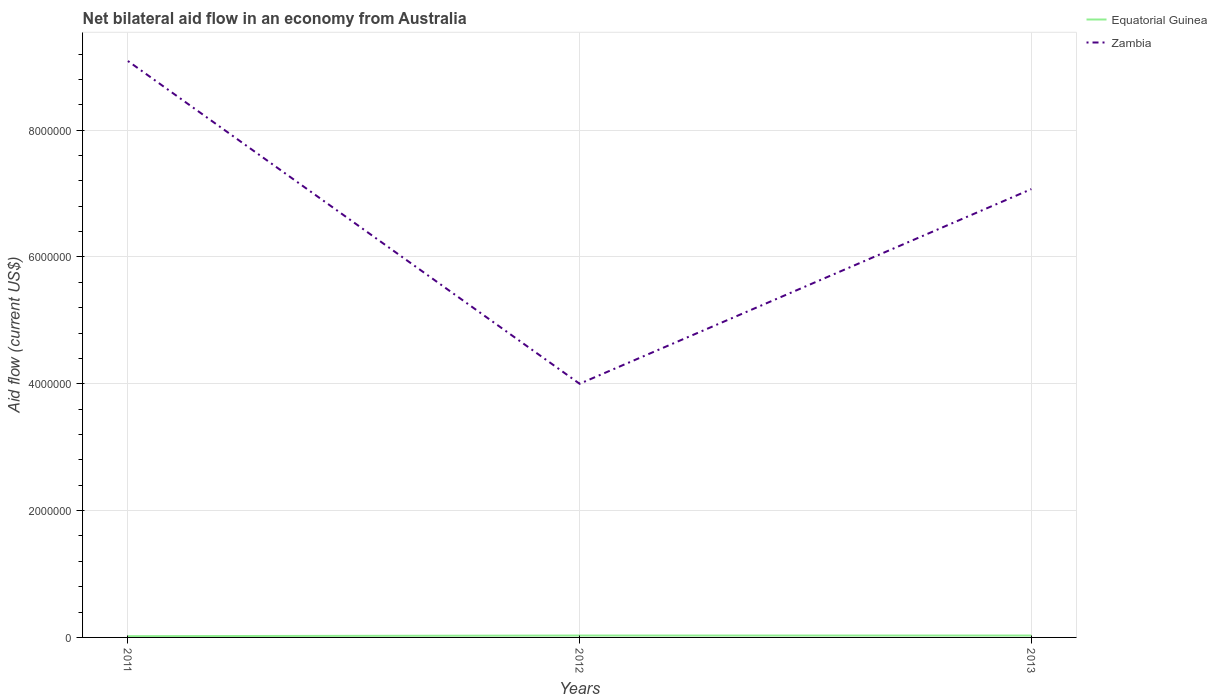Does the line corresponding to Zambia intersect with the line corresponding to Equatorial Guinea?
Make the answer very short. No. Across all years, what is the maximum net bilateral aid flow in Zambia?
Make the answer very short. 4.00e+06. What is the total net bilateral aid flow in Equatorial Guinea in the graph?
Your answer should be compact. 0. What is the difference between the highest and the second highest net bilateral aid flow in Equatorial Guinea?
Your answer should be very brief. 10000. How many years are there in the graph?
Provide a short and direct response. 3. Does the graph contain any zero values?
Keep it short and to the point. No. Does the graph contain grids?
Provide a short and direct response. Yes. How are the legend labels stacked?
Provide a short and direct response. Vertical. What is the title of the graph?
Your answer should be compact. Net bilateral aid flow in an economy from Australia. What is the Aid flow (current US$) in Equatorial Guinea in 2011?
Keep it short and to the point. 2.00e+04. What is the Aid flow (current US$) of Zambia in 2011?
Ensure brevity in your answer.  9.09e+06. What is the Aid flow (current US$) of Equatorial Guinea in 2012?
Your answer should be very brief. 3.00e+04. What is the Aid flow (current US$) in Zambia in 2012?
Offer a very short reply. 4.00e+06. What is the Aid flow (current US$) in Zambia in 2013?
Offer a terse response. 7.07e+06. Across all years, what is the maximum Aid flow (current US$) in Zambia?
Your answer should be compact. 9.09e+06. Across all years, what is the minimum Aid flow (current US$) of Zambia?
Offer a terse response. 4.00e+06. What is the total Aid flow (current US$) of Zambia in the graph?
Give a very brief answer. 2.02e+07. What is the difference between the Aid flow (current US$) of Equatorial Guinea in 2011 and that in 2012?
Offer a very short reply. -10000. What is the difference between the Aid flow (current US$) of Zambia in 2011 and that in 2012?
Make the answer very short. 5.09e+06. What is the difference between the Aid flow (current US$) of Zambia in 2011 and that in 2013?
Your answer should be very brief. 2.02e+06. What is the difference between the Aid flow (current US$) in Zambia in 2012 and that in 2013?
Offer a very short reply. -3.07e+06. What is the difference between the Aid flow (current US$) in Equatorial Guinea in 2011 and the Aid flow (current US$) in Zambia in 2012?
Your answer should be compact. -3.98e+06. What is the difference between the Aid flow (current US$) of Equatorial Guinea in 2011 and the Aid flow (current US$) of Zambia in 2013?
Offer a terse response. -7.05e+06. What is the difference between the Aid flow (current US$) of Equatorial Guinea in 2012 and the Aid flow (current US$) of Zambia in 2013?
Your answer should be very brief. -7.04e+06. What is the average Aid flow (current US$) of Equatorial Guinea per year?
Your response must be concise. 2.67e+04. What is the average Aid flow (current US$) in Zambia per year?
Offer a terse response. 6.72e+06. In the year 2011, what is the difference between the Aid flow (current US$) of Equatorial Guinea and Aid flow (current US$) of Zambia?
Ensure brevity in your answer.  -9.07e+06. In the year 2012, what is the difference between the Aid flow (current US$) in Equatorial Guinea and Aid flow (current US$) in Zambia?
Offer a very short reply. -3.97e+06. In the year 2013, what is the difference between the Aid flow (current US$) in Equatorial Guinea and Aid flow (current US$) in Zambia?
Provide a succinct answer. -7.04e+06. What is the ratio of the Aid flow (current US$) in Equatorial Guinea in 2011 to that in 2012?
Offer a terse response. 0.67. What is the ratio of the Aid flow (current US$) of Zambia in 2011 to that in 2012?
Offer a very short reply. 2.27. What is the ratio of the Aid flow (current US$) in Equatorial Guinea in 2012 to that in 2013?
Make the answer very short. 1. What is the ratio of the Aid flow (current US$) of Zambia in 2012 to that in 2013?
Give a very brief answer. 0.57. What is the difference between the highest and the second highest Aid flow (current US$) in Zambia?
Your response must be concise. 2.02e+06. What is the difference between the highest and the lowest Aid flow (current US$) of Zambia?
Provide a succinct answer. 5.09e+06. 